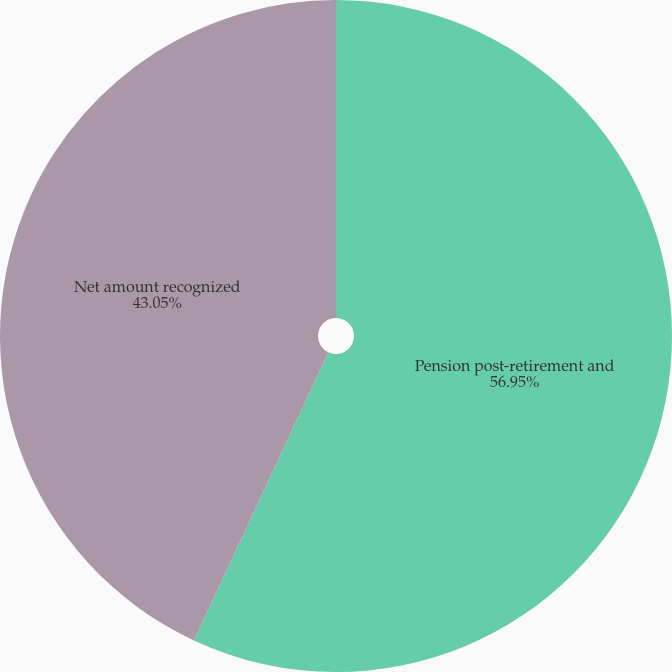Convert chart to OTSL. <chart><loc_0><loc_0><loc_500><loc_500><pie_chart><fcel>Pension post-retirement and<fcel>Net amount recognized<nl><fcel>56.95%<fcel>43.05%<nl></chart> 